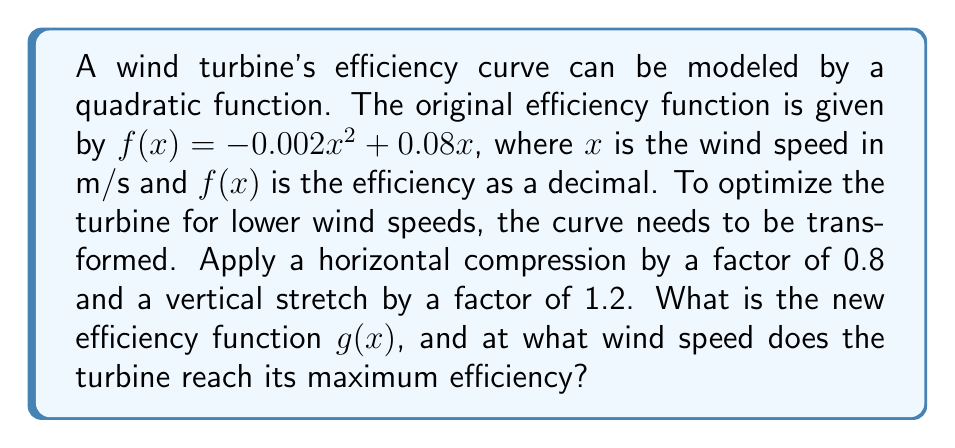Solve this math problem. To solve this problem, we'll follow these steps:

1) First, let's apply the transformations to the original function $f(x) = -0.002x^2 + 0.08x$:

   - Horizontal compression by a factor of 0.8: Replace $x$ with $\frac{x}{0.8}$
   - Vertical stretch by a factor of 1.2: Multiply the entire function by 1.2

2) Applying these transformations:

   $g(x) = 1.2f(\frac{x}{0.8})$

3) Substituting the original function:

   $g(x) = 1.2(-0.002(\frac{x}{0.8})^2 + 0.08(\frac{x}{0.8}))$

4) Simplify:

   $g(x) = 1.2(-0.002(\frac{x^2}{0.64}) + \frac{0.08x}{0.8})$
   
   $g(x) = 1.2(-\frac{0.002x^2}{0.64} + 0.1x)$
   
   $g(x) = -\frac{0.0024x^2}{0.64} + 0.12x$
   
   $g(x) = -0.00375x^2 + 0.12x$

5) To find the maximum efficiency, we need to find the vertex of this parabola. For a quadratic function in the form $ax^2 + bx + c$, the x-coordinate of the vertex is given by $x = -\frac{b}{2a}$.

   Here, $a = -0.00375$ and $b = 0.12$

   $x = -\frac{0.12}{2(-0.00375)} = 16$ m/s

Therefore, the turbine reaches its maximum efficiency at a wind speed of 16 m/s.
Answer: The new efficiency function is $g(x) = -0.00375x^2 + 0.12x$, and the turbine reaches its maximum efficiency at a wind speed of 16 m/s. 